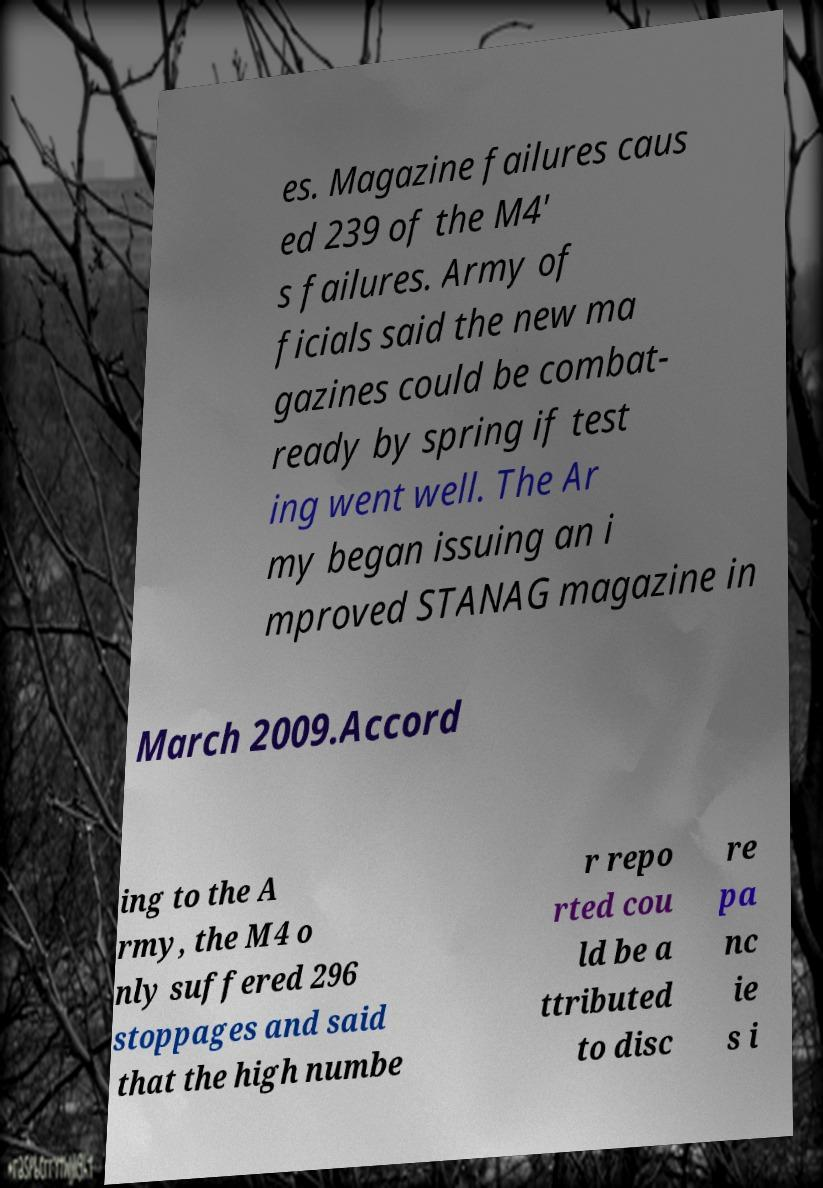Please read and relay the text visible in this image. What does it say? es. Magazine failures caus ed 239 of the M4' s failures. Army of ficials said the new ma gazines could be combat- ready by spring if test ing went well. The Ar my began issuing an i mproved STANAG magazine in March 2009.Accord ing to the A rmy, the M4 o nly suffered 296 stoppages and said that the high numbe r repo rted cou ld be a ttributed to disc re pa nc ie s i 